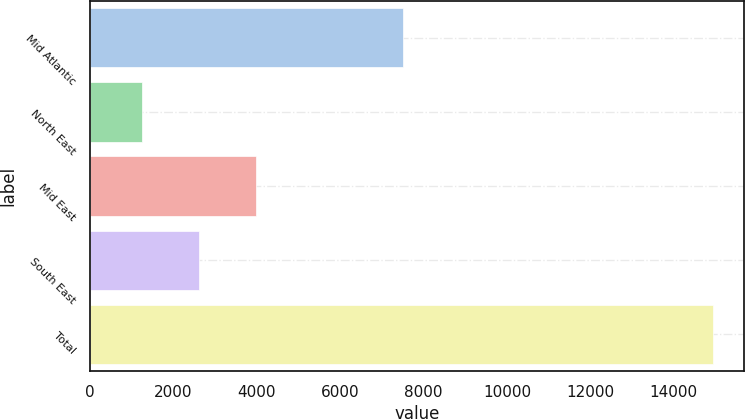Convert chart. <chart><loc_0><loc_0><loc_500><loc_500><bar_chart><fcel>Mid Atlantic<fcel>North East<fcel>Mid East<fcel>South East<fcel>Total<nl><fcel>7512<fcel>1246<fcel>3982.4<fcel>2614.2<fcel>14928<nl></chart> 